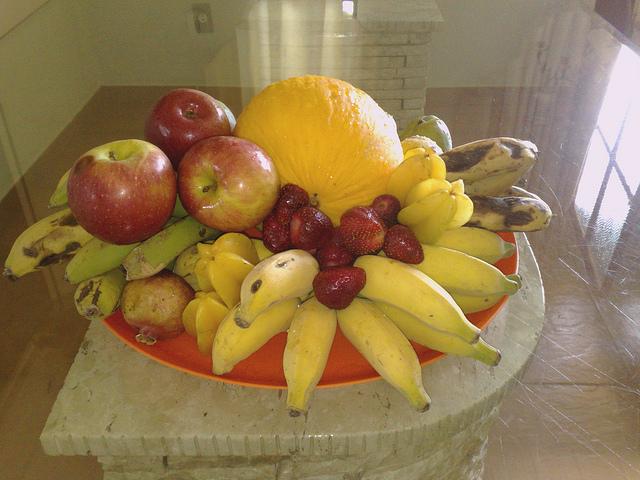Are they ripe enough to eat?
Keep it brief. Yes. How many apples are there?
Quick response, please. 3. What is the design of this arrangement?
Short answer required. Star. Do you see a tomato?
Keep it brief. No. Is there fruit on the plate?
Be succinct. Yes. How many different fruit are in this bowl?
Keep it brief. 6. Can you make a fruit salad with these fruits?
Answer briefly. Yes. 